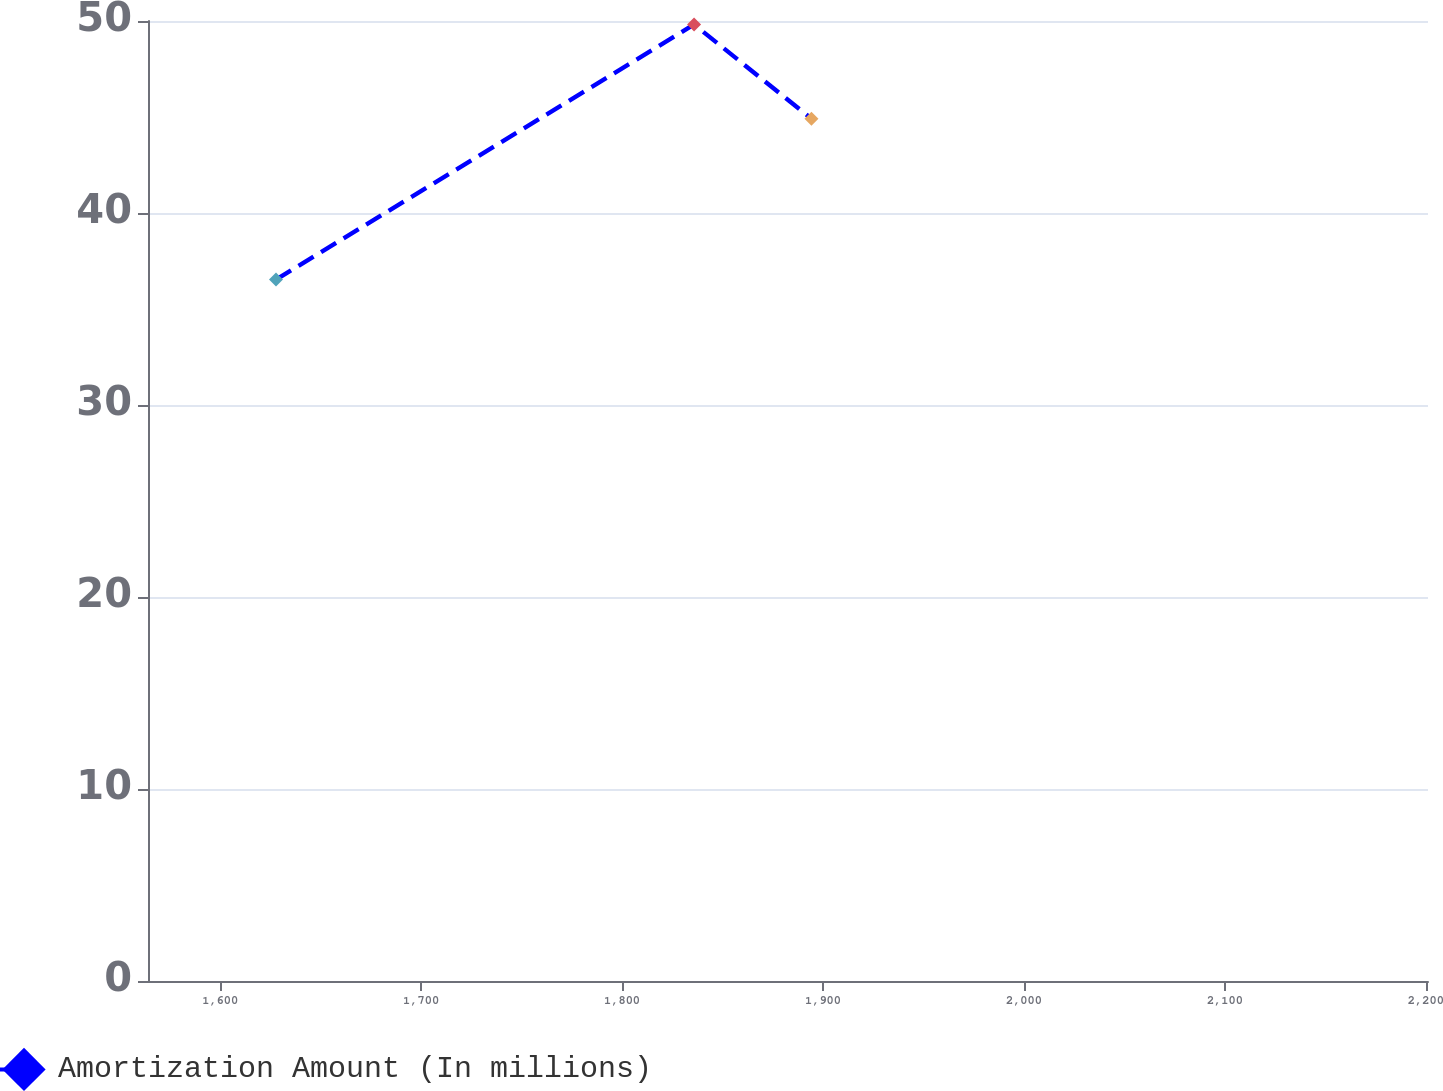<chart> <loc_0><loc_0><loc_500><loc_500><line_chart><ecel><fcel>Amortization Amount (In millions)<nl><fcel>1627.78<fcel>36.53<nl><fcel>1835.82<fcel>49.82<nl><fcel>1894.25<fcel>44.91<nl><fcel>2206.33<fcel>48.61<nl><fcel>2264.76<fcel>39.65<nl></chart> 